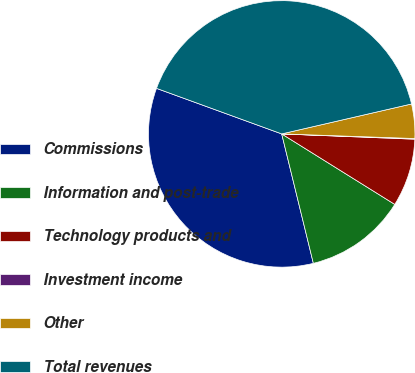Convert chart to OTSL. <chart><loc_0><loc_0><loc_500><loc_500><pie_chart><fcel>Commissions<fcel>Information and post-trade<fcel>Technology products and<fcel>Investment income<fcel>Other<fcel>Total revenues<nl><fcel>34.37%<fcel>12.31%<fcel>8.24%<fcel>0.08%<fcel>4.16%<fcel>40.84%<nl></chart> 